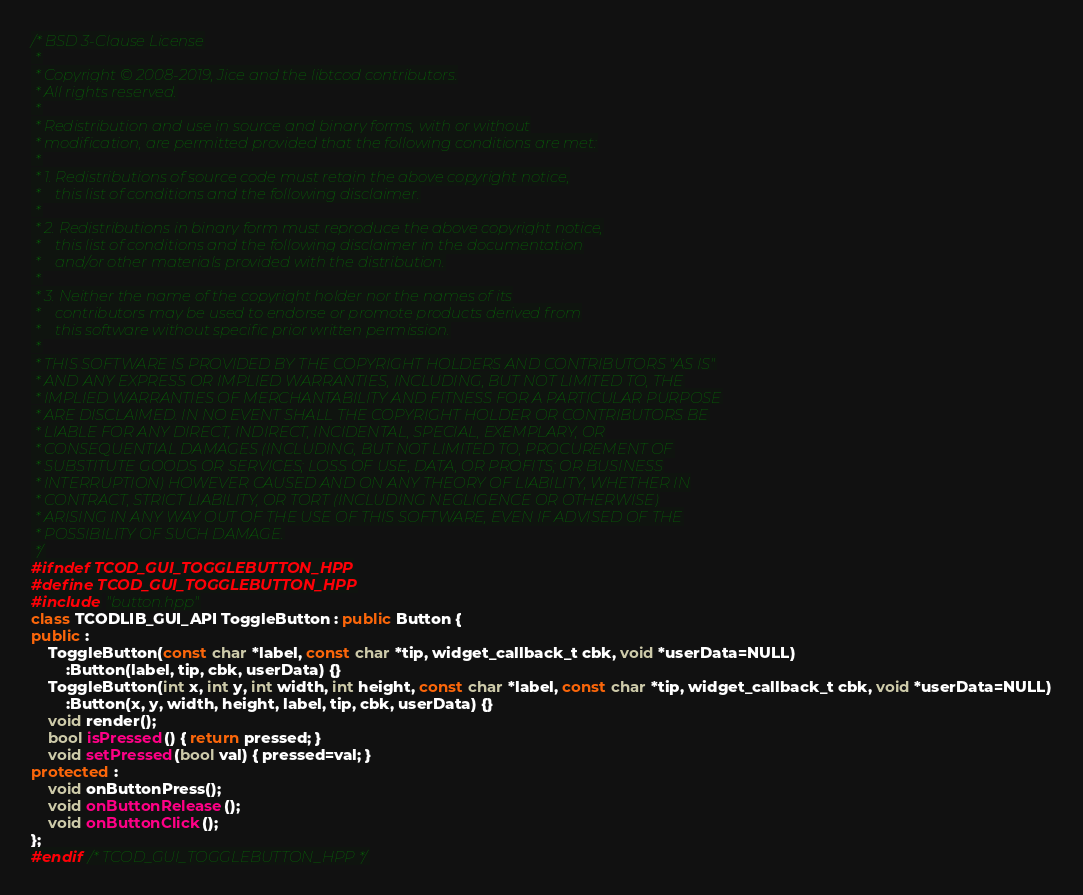<code> <loc_0><loc_0><loc_500><loc_500><_C++_>/* BSD 3-Clause License
 *
 * Copyright © 2008-2019, Jice and the libtcod contributors.
 * All rights reserved.
 *
 * Redistribution and use in source and binary forms, with or without
 * modification, are permitted provided that the following conditions are met:
 *
 * 1. Redistributions of source code must retain the above copyright notice,
 *    this list of conditions and the following disclaimer.
 *
 * 2. Redistributions in binary form must reproduce the above copyright notice,
 *    this list of conditions and the following disclaimer in the documentation
 *    and/or other materials provided with the distribution.
 *
 * 3. Neither the name of the copyright holder nor the names of its
 *    contributors may be used to endorse or promote products derived from
 *    this software without specific prior written permission.
 *
 * THIS SOFTWARE IS PROVIDED BY THE COPYRIGHT HOLDERS AND CONTRIBUTORS "AS IS"
 * AND ANY EXPRESS OR IMPLIED WARRANTIES, INCLUDING, BUT NOT LIMITED TO, THE
 * IMPLIED WARRANTIES OF MERCHANTABILITY AND FITNESS FOR A PARTICULAR PURPOSE
 * ARE DISCLAIMED. IN NO EVENT SHALL THE COPYRIGHT HOLDER OR CONTRIBUTORS BE
 * LIABLE FOR ANY DIRECT, INDIRECT, INCIDENTAL, SPECIAL, EXEMPLARY, OR
 * CONSEQUENTIAL DAMAGES (INCLUDING, BUT NOT LIMITED TO, PROCUREMENT OF
 * SUBSTITUTE GOODS OR SERVICES; LOSS OF USE, DATA, OR PROFITS; OR BUSINESS
 * INTERRUPTION) HOWEVER CAUSED AND ON ANY THEORY OF LIABILITY, WHETHER IN
 * CONTRACT, STRICT LIABILITY, OR TORT (INCLUDING NEGLIGENCE OR OTHERWISE)
 * ARISING IN ANY WAY OUT OF THE USE OF THIS SOFTWARE, EVEN IF ADVISED OF THE
 * POSSIBILITY OF SUCH DAMAGE.
 */
#ifndef TCOD_GUI_TOGGLEBUTTON_HPP
#define TCOD_GUI_TOGGLEBUTTON_HPP
#include "button.hpp"
class TCODLIB_GUI_API ToggleButton : public Button {
public :
	ToggleButton(const char *label, const char *tip, widget_callback_t cbk, void *userData=NULL)
		:Button(label, tip, cbk, userData) {}
	ToggleButton(int x, int y, int width, int height, const char *label, const char *tip, widget_callback_t cbk, void *userData=NULL)
		:Button(x, y, width, height, label, tip, cbk, userData) {}
	void render();
	bool isPressed() { return pressed; }
	void setPressed(bool val) { pressed=val; }
protected :
	void onButtonPress();
	void onButtonRelease();
	void onButtonClick();
};
#endif /* TCOD_GUI_TOGGLEBUTTON_HPP */
</code> 